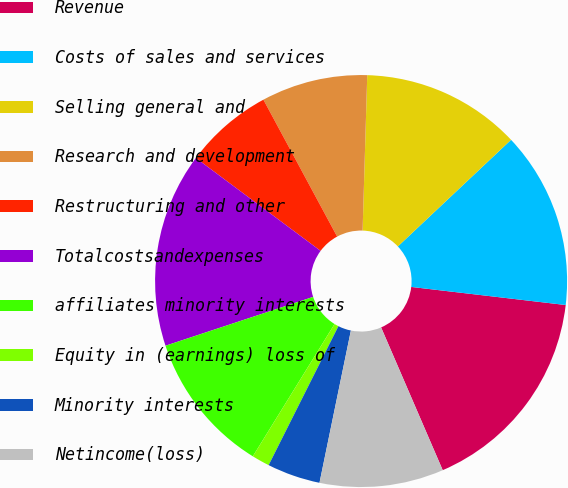Convert chart. <chart><loc_0><loc_0><loc_500><loc_500><pie_chart><fcel>Revenue<fcel>Costs of sales and services<fcel>Selling general and<fcel>Research and development<fcel>Restructuring and other<fcel>Totalcostsandexpenses<fcel>affiliates minority interests<fcel>Equity in (earnings) loss of<fcel>Minority interests<fcel>Netincome(loss)<nl><fcel>16.66%<fcel>13.88%<fcel>12.5%<fcel>8.34%<fcel>6.95%<fcel>15.27%<fcel>11.11%<fcel>1.4%<fcel>4.17%<fcel>9.72%<nl></chart> 